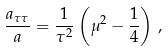<formula> <loc_0><loc_0><loc_500><loc_500>\frac { a _ { \tau \tau } } { a } = \frac { 1 } { \tau ^ { 2 } } \left ( \mu ^ { 2 } - \frac { 1 } { 4 } \right ) \, ,</formula> 